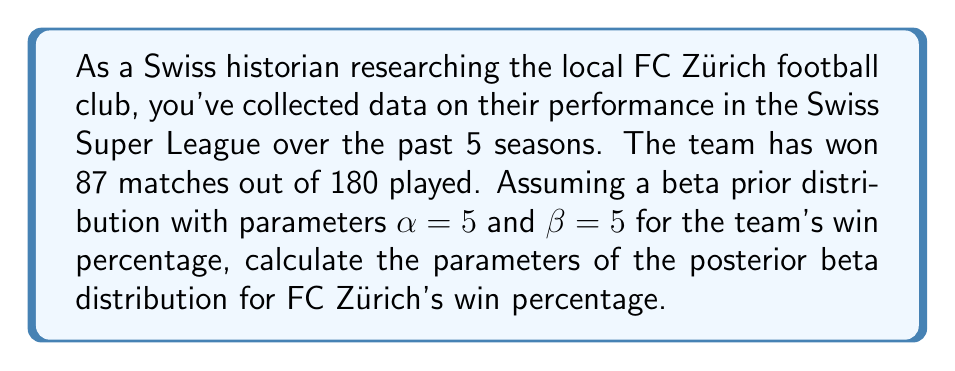Show me your answer to this math problem. To solve this problem, we'll use Bayesian inference with a beta-binomial model. The beta distribution is conjugate to the binomial distribution, which makes it convenient for updating our beliefs about a probability (in this case, the win percentage) based on observed data.

Given:
- Prior distribution: Beta($\alpha=5$, $\beta=5$)
- Data: 87 wins out of 180 matches

Step 1: Identify the likelihood function
The likelihood function follows a binomial distribution:
$$ P(data|\theta) \propto \theta^{wins} (1-\theta)^{losses} $$
where $\theta$ is the win percentage.

Step 2: Combine prior and likelihood
The posterior distribution is proportional to the product of the prior and likelihood:
$$ P(\theta|data) \propto P(\theta) \cdot P(data|\theta) $$

For a beta prior and binomial likelihood, the posterior is also a beta distribution with updated parameters:
$$ \alpha_{posterior} = \alpha_{prior} + wins $$
$$ \beta_{posterior} = \beta_{prior} + losses $$

Step 3: Calculate the posterior parameters
$\alpha_{posterior} = 5 + 87 = 92$
$\beta_{posterior} = 5 + (180 - 87) = 98$

Therefore, the posterior distribution is Beta(92, 98).
Answer: The posterior distribution for FC Zürich's win percentage is Beta(92, 98). 